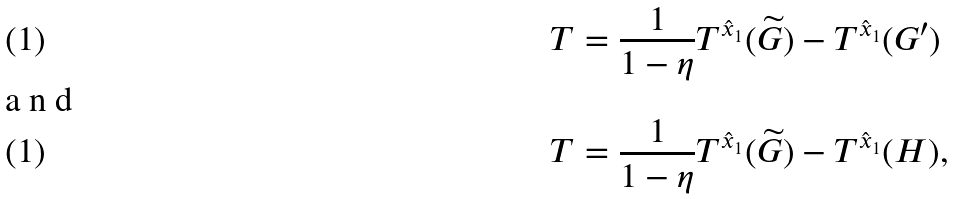Convert formula to latex. <formula><loc_0><loc_0><loc_500><loc_500>T & = \frac { 1 } { 1 - \eta } T ^ { \hat { x } _ { 1 } } ( \widetilde { G } ) - T ^ { \hat { x } _ { 1 } } ( G ^ { \prime } ) \shortintertext { a n d } T & = \frac { 1 } { 1 - \eta } T ^ { \hat { x } _ { 1 } } ( \widetilde { G } ) - T ^ { \hat { x } _ { 1 } } ( H ) ,</formula> 